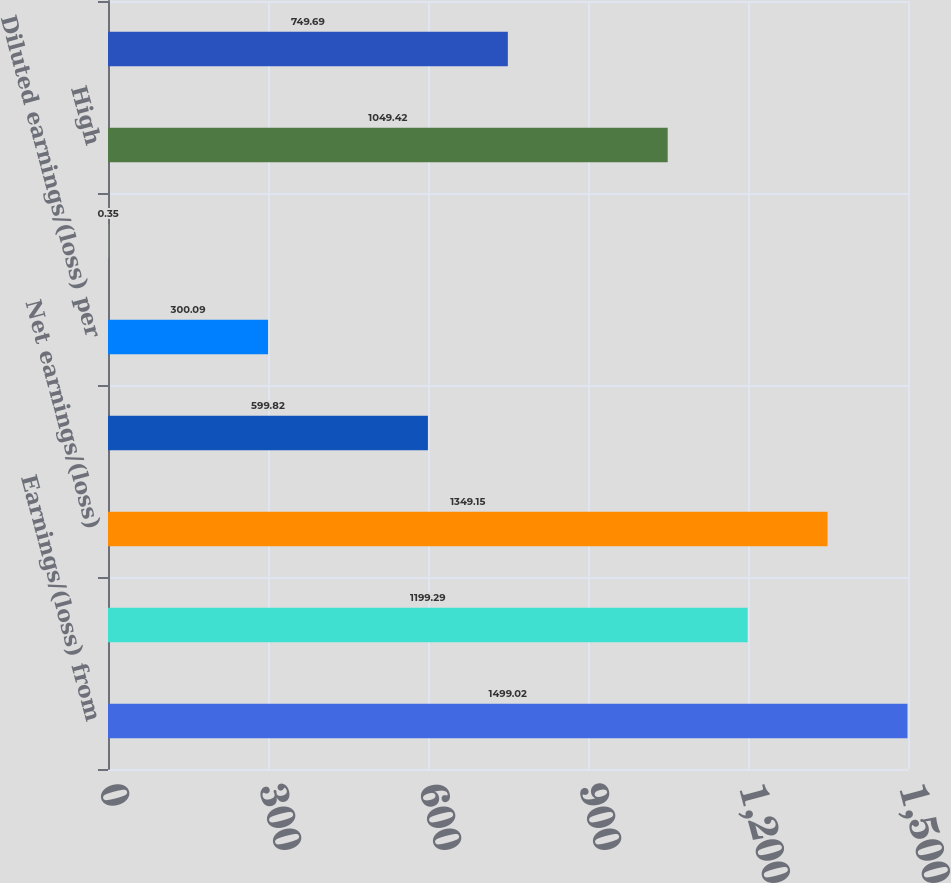Convert chart to OTSL. <chart><loc_0><loc_0><loc_500><loc_500><bar_chart><fcel>Earnings/(loss) from<fcel>Net earnings/(loss) from<fcel>Net earnings/(loss)<fcel>Basic earnings/(loss) per<fcel>Diluted earnings/(loss) per<fcel>Cash dividends paid per share<fcel>High<fcel>Low<nl><fcel>1499.02<fcel>1199.29<fcel>1349.15<fcel>599.82<fcel>300.09<fcel>0.35<fcel>1049.42<fcel>749.69<nl></chart> 